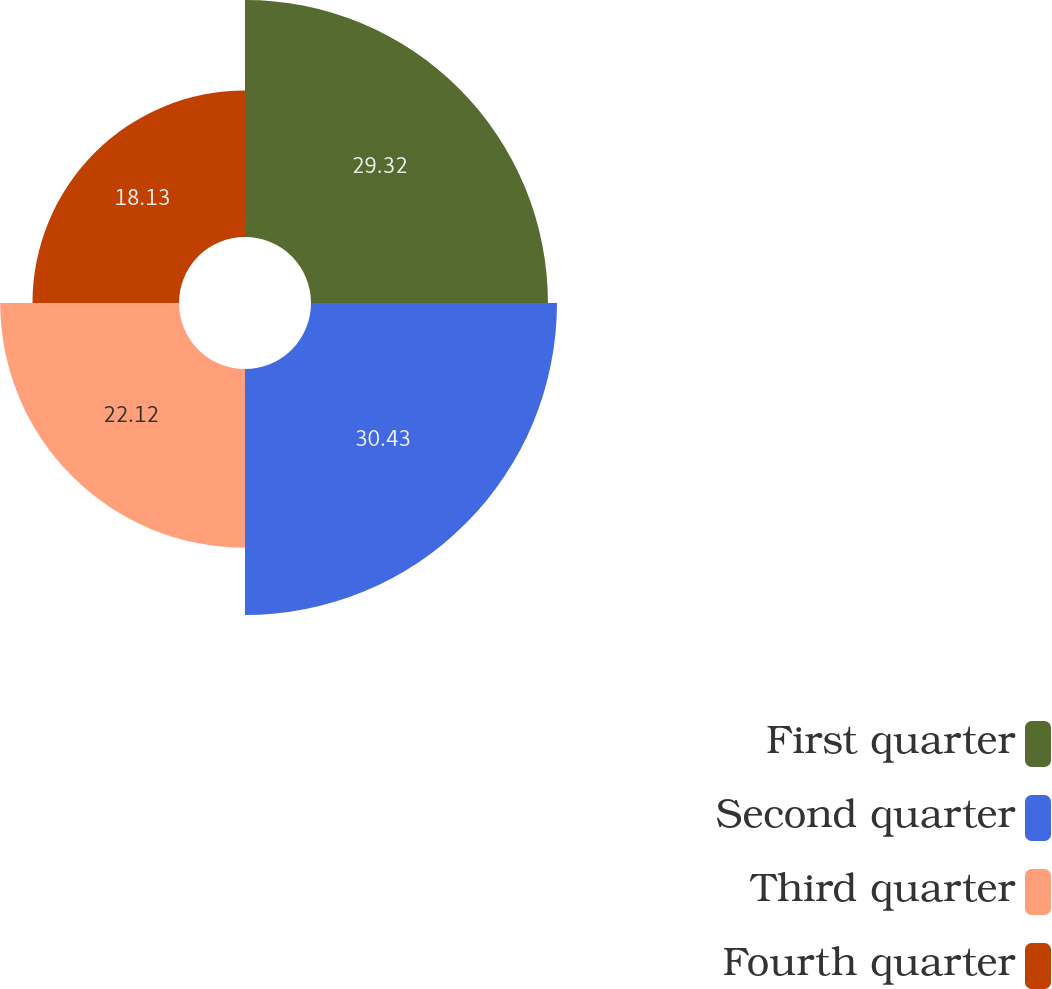Convert chart. <chart><loc_0><loc_0><loc_500><loc_500><pie_chart><fcel>First quarter<fcel>Second quarter<fcel>Third quarter<fcel>Fourth quarter<nl><fcel>29.32%<fcel>30.44%<fcel>22.12%<fcel>18.13%<nl></chart> 